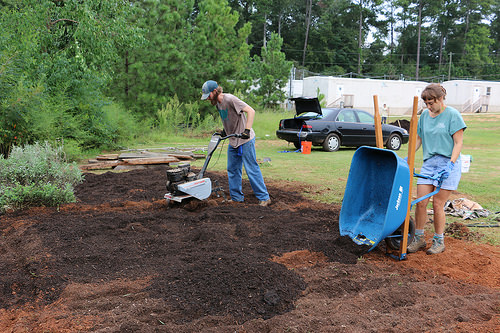<image>
Is there a car in front of the person? No. The car is not in front of the person. The spatial positioning shows a different relationship between these objects. 